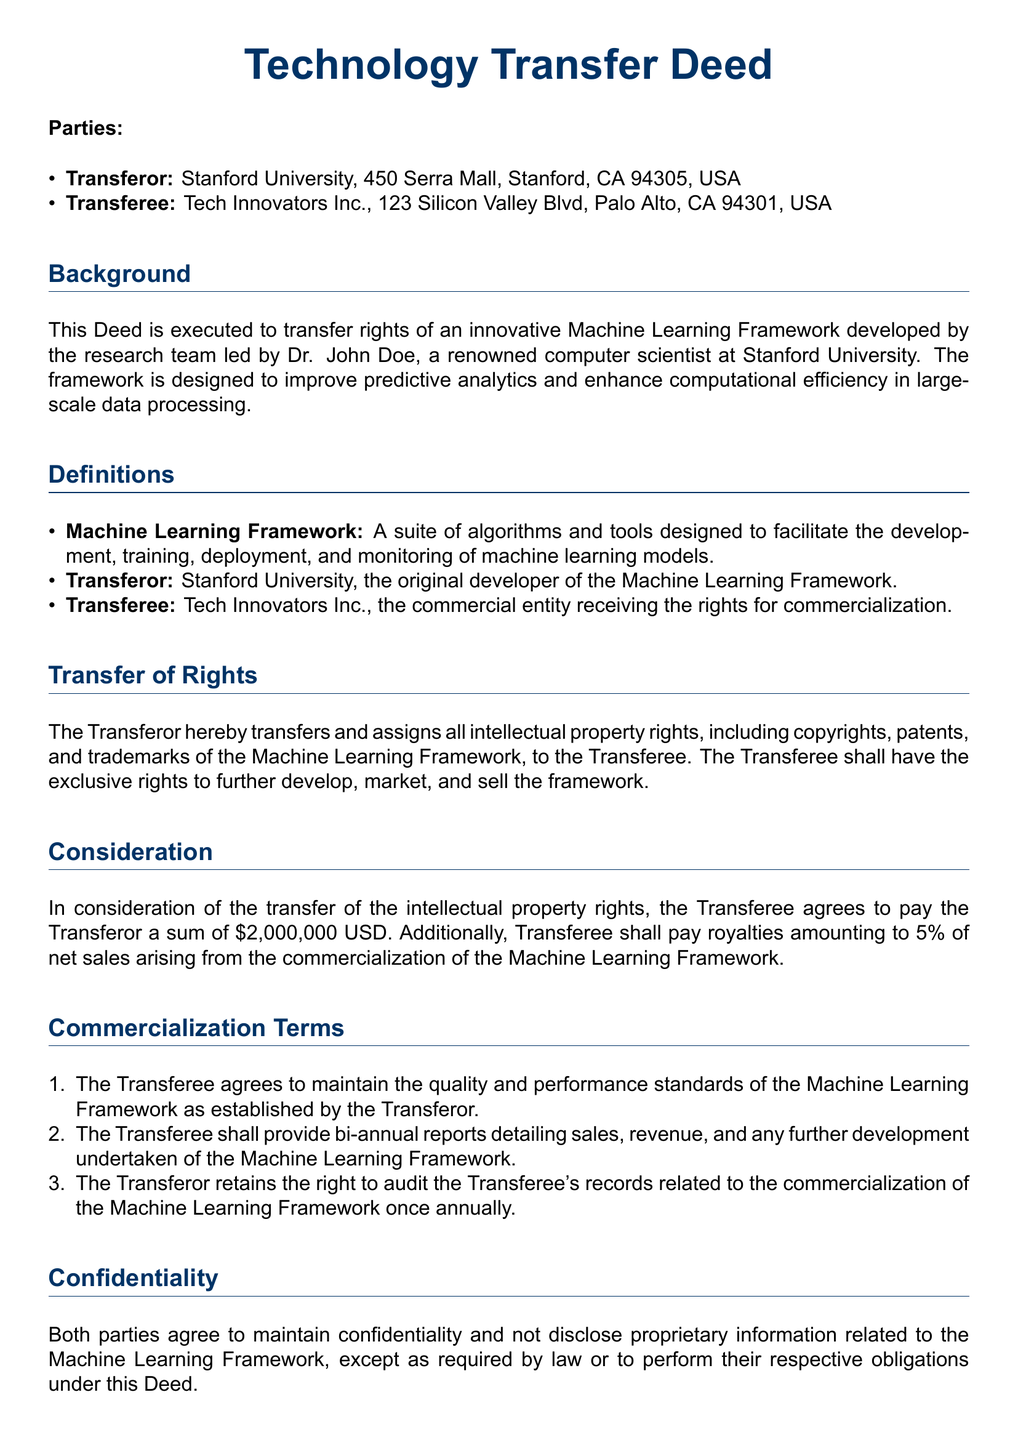What is the name of the Transferor? The Transferor is the original developer of the Machine Learning Framework, which is Stanford University.
Answer: Stanford University What is the payment amount for the transfer of rights? The amount to be paid by the Transferee for the transfer of rights as stated in the document is a sum of 2,000,000 USD.
Answer: 2,000,000 USD What percentage of royalties is payable by the Transferee? The document specifies that the Transferee has to pay royalties amounting to 5% of net sales from the commercialization.
Answer: 5% How long will the Deed remain in force? The duration of the Deed as mentioned is ten years from the date of execution.
Answer: ten years Who is the Principal Investigator at Stanford University? The document identifies Dr. John Doe as the Principal Investigator leading the research team.
Answer: Dr. John Doe What action can terminate the Deed? The Deed allows for termination with a six-month written notice in case of a material breach that is not rectified.
Answer: Material breach What is required from the Transferee regarding performance standards? The Transferee agrees to maintain quality and performance standards established by the Transferor for the Machine Learning Framework.
Answer: Maintain quality standards What must the Transferee provide bi-annually? Per the document, the Transferee must provide bi-annual reports detailing sales and revenue related to the Machine Learning Framework.
Answer: Bi-annual reports Which state’s law governs this Deed? The governing law for this Deed, as indicated, is the law of the State of California, USA.
Answer: California 